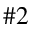<formula> <loc_0><loc_0><loc_500><loc_500>\# 2</formula> 